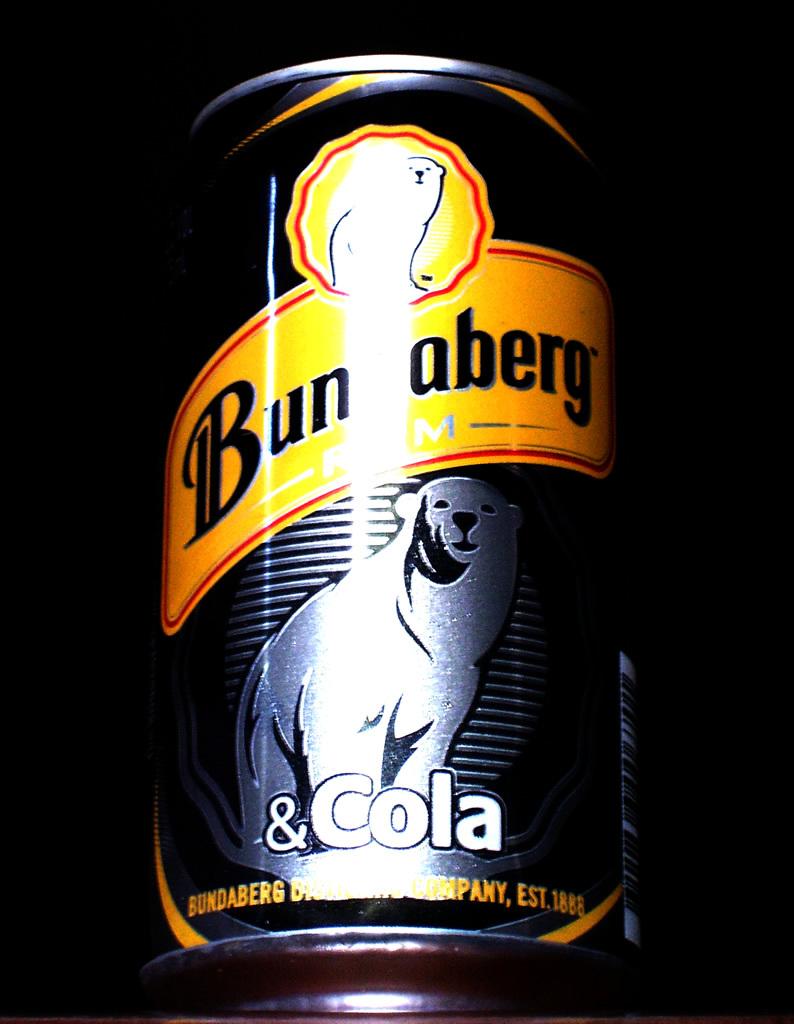When was the company established?
Keep it short and to the point. 1888. Is cola on the can?
Ensure brevity in your answer.  Yes. 